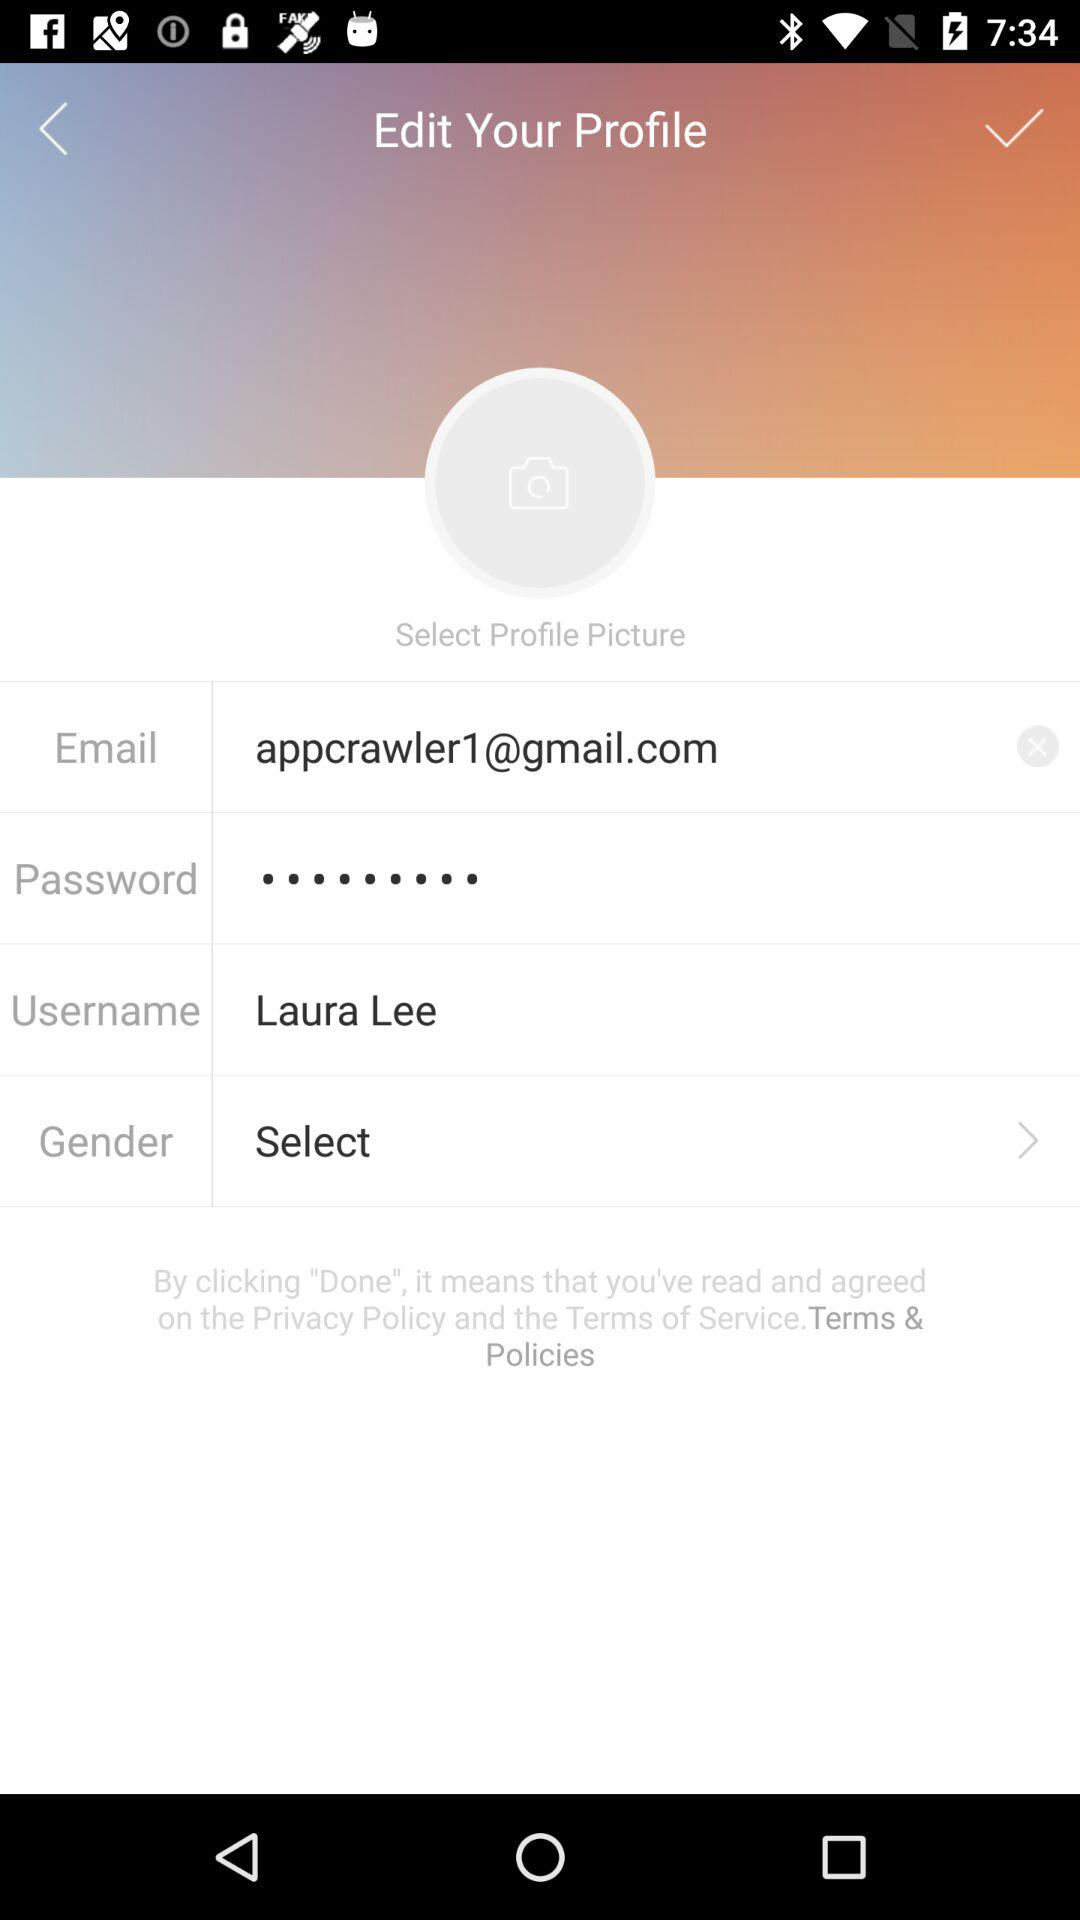What is the username shown? The user name is Laura Lee. 